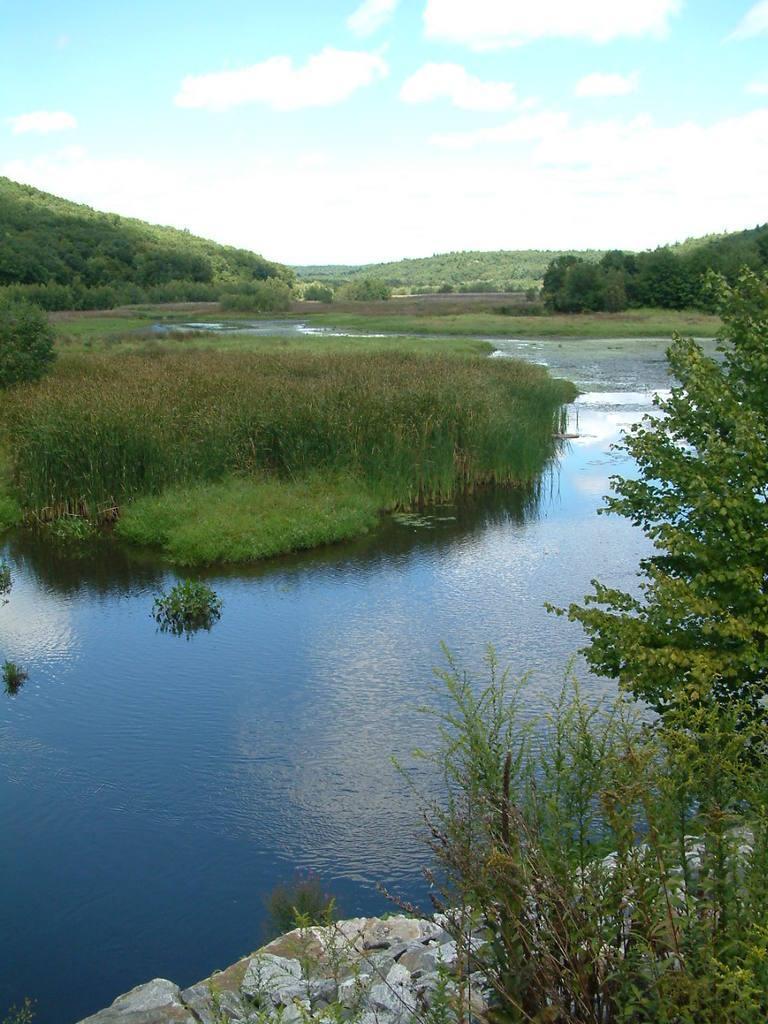Describe this image in one or two sentences. In this image we can see plants, grass, water, trees, stones, hills, sky and clouds. 